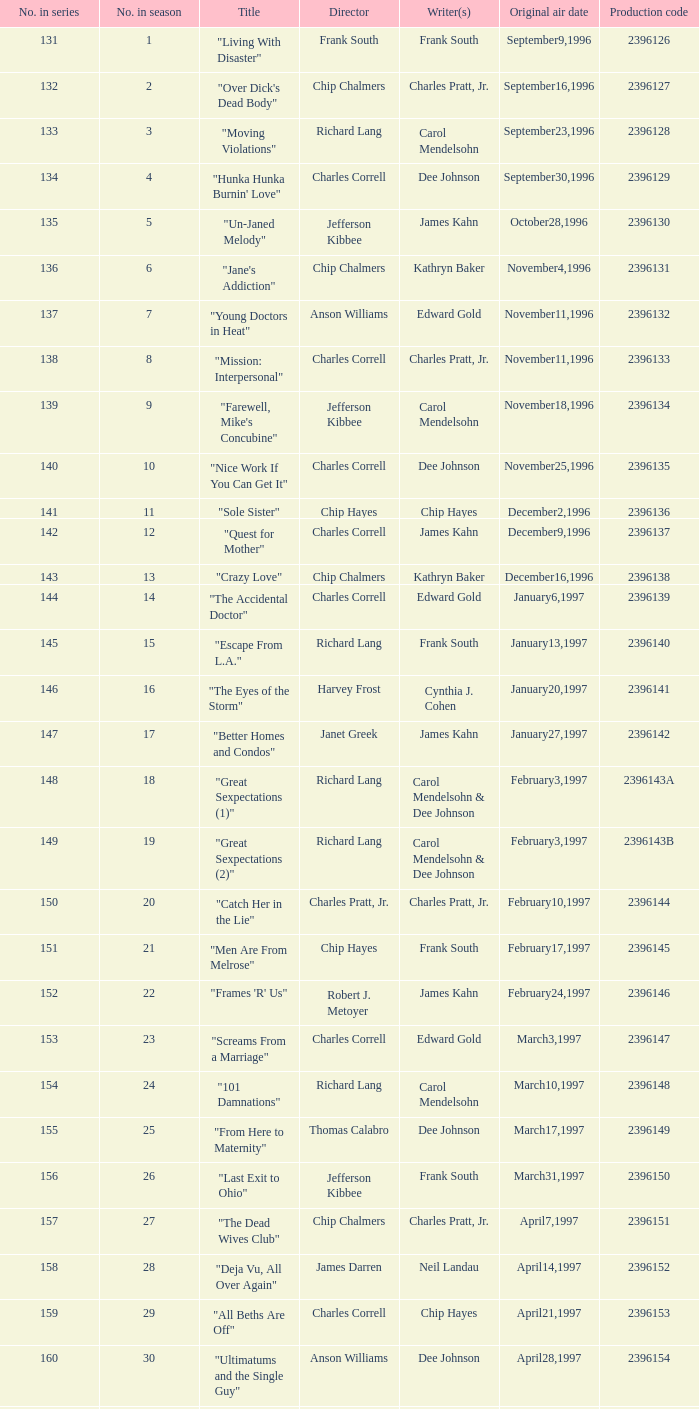Who directed the episode "Great Sexpectations (2)"? Richard Lang. Would you be able to parse every entry in this table? {'header': ['No. in series', 'No. in season', 'Title', 'Director', 'Writer(s)', 'Original air date', 'Production code'], 'rows': [['131', '1', '"Living With Disaster"', 'Frank South', 'Frank South', 'September9,1996', '2396126'], ['132', '2', '"Over Dick\'s Dead Body"', 'Chip Chalmers', 'Charles Pratt, Jr.', 'September16,1996', '2396127'], ['133', '3', '"Moving Violations"', 'Richard Lang', 'Carol Mendelsohn', 'September23,1996', '2396128'], ['134', '4', '"Hunka Hunka Burnin\' Love"', 'Charles Correll', 'Dee Johnson', 'September30,1996', '2396129'], ['135', '5', '"Un-Janed Melody"', 'Jefferson Kibbee', 'James Kahn', 'October28,1996', '2396130'], ['136', '6', '"Jane\'s Addiction"', 'Chip Chalmers', 'Kathryn Baker', 'November4,1996', '2396131'], ['137', '7', '"Young Doctors in Heat"', 'Anson Williams', 'Edward Gold', 'November11,1996', '2396132'], ['138', '8', '"Mission: Interpersonal"', 'Charles Correll', 'Charles Pratt, Jr.', 'November11,1996', '2396133'], ['139', '9', '"Farewell, Mike\'s Concubine"', 'Jefferson Kibbee', 'Carol Mendelsohn', 'November18,1996', '2396134'], ['140', '10', '"Nice Work If You Can Get It"', 'Charles Correll', 'Dee Johnson', 'November25,1996', '2396135'], ['141', '11', '"Sole Sister"', 'Chip Hayes', 'Chip Hayes', 'December2,1996', '2396136'], ['142', '12', '"Quest for Mother"', 'Charles Correll', 'James Kahn', 'December9,1996', '2396137'], ['143', '13', '"Crazy Love"', 'Chip Chalmers', 'Kathryn Baker', 'December16,1996', '2396138'], ['144', '14', '"The Accidental Doctor"', 'Charles Correll', 'Edward Gold', 'January6,1997', '2396139'], ['145', '15', '"Escape From L.A."', 'Richard Lang', 'Frank South', 'January13,1997', '2396140'], ['146', '16', '"The Eyes of the Storm"', 'Harvey Frost', 'Cynthia J. Cohen', 'January20,1997', '2396141'], ['147', '17', '"Better Homes and Condos"', 'Janet Greek', 'James Kahn', 'January27,1997', '2396142'], ['148', '18', '"Great Sexpectations (1)"', 'Richard Lang', 'Carol Mendelsohn & Dee Johnson', 'February3,1997', '2396143A'], ['149', '19', '"Great Sexpectations (2)"', 'Richard Lang', 'Carol Mendelsohn & Dee Johnson', 'February3,1997', '2396143B'], ['150', '20', '"Catch Her in the Lie"', 'Charles Pratt, Jr.', 'Charles Pratt, Jr.', 'February10,1997', '2396144'], ['151', '21', '"Men Are From Melrose"', 'Chip Hayes', 'Frank South', 'February17,1997', '2396145'], ['152', '22', '"Frames \'R\' Us"', 'Robert J. Metoyer', 'James Kahn', 'February24,1997', '2396146'], ['153', '23', '"Screams From a Marriage"', 'Charles Correll', 'Edward Gold', 'March3,1997', '2396147'], ['154', '24', '"101 Damnations"', 'Richard Lang', 'Carol Mendelsohn', 'March10,1997', '2396148'], ['155', '25', '"From Here to Maternity"', 'Thomas Calabro', 'Dee Johnson', 'March17,1997', '2396149'], ['156', '26', '"Last Exit to Ohio"', 'Jefferson Kibbee', 'Frank South', 'March31,1997', '2396150'], ['157', '27', '"The Dead Wives Club"', 'Chip Chalmers', 'Charles Pratt, Jr.', 'April7,1997', '2396151'], ['158', '28', '"Deja Vu, All Over Again"', 'James Darren', 'Neil Landau', 'April14,1997', '2396152'], ['159', '29', '"All Beths Are Off"', 'Charles Correll', 'Chip Hayes', 'April21,1997', '2396153'], ['160', '30', '"Ultimatums and the Single Guy"', 'Anson Williams', 'Dee Johnson', 'April28,1997', '2396154'], ['161', '31', '"Going Places"', 'Charles Pratt, Jr.', 'Carol Mendelsohn', 'May5,1997', '2396155'], ['162', '32', '"Secrets and Lies and More Lies"', 'Frank South', 'Frank South', 'May12,1997', '2396156'], ['163', '33', '"Who\'s Afraid of Amanda Woodward? (1)"', 'Charles Correll', 'Charles Pratt, Jr.', 'May19,1997', '2396157A']]} 